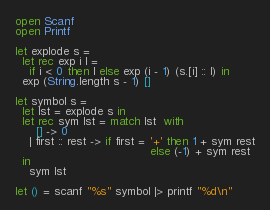Convert code to text. <code><loc_0><loc_0><loc_500><loc_500><_OCaml_>open Scanf
open Printf

let explode s =
  let rec exp i l =
    if i < 0 then l else exp (i - 1) (s.[i] :: l) in
  exp (String.length s - 1) []

let symbol s =
  let lst = explode s in
  let rec sym lst = match lst  with
      [] -> 0
    | first :: rest -> if first = '+' then 1 + sym rest
                                      else (-1) + sym rest
  in
    sym lst

let () = scanf "%s" symbol |> printf "%d\n"
</code> 